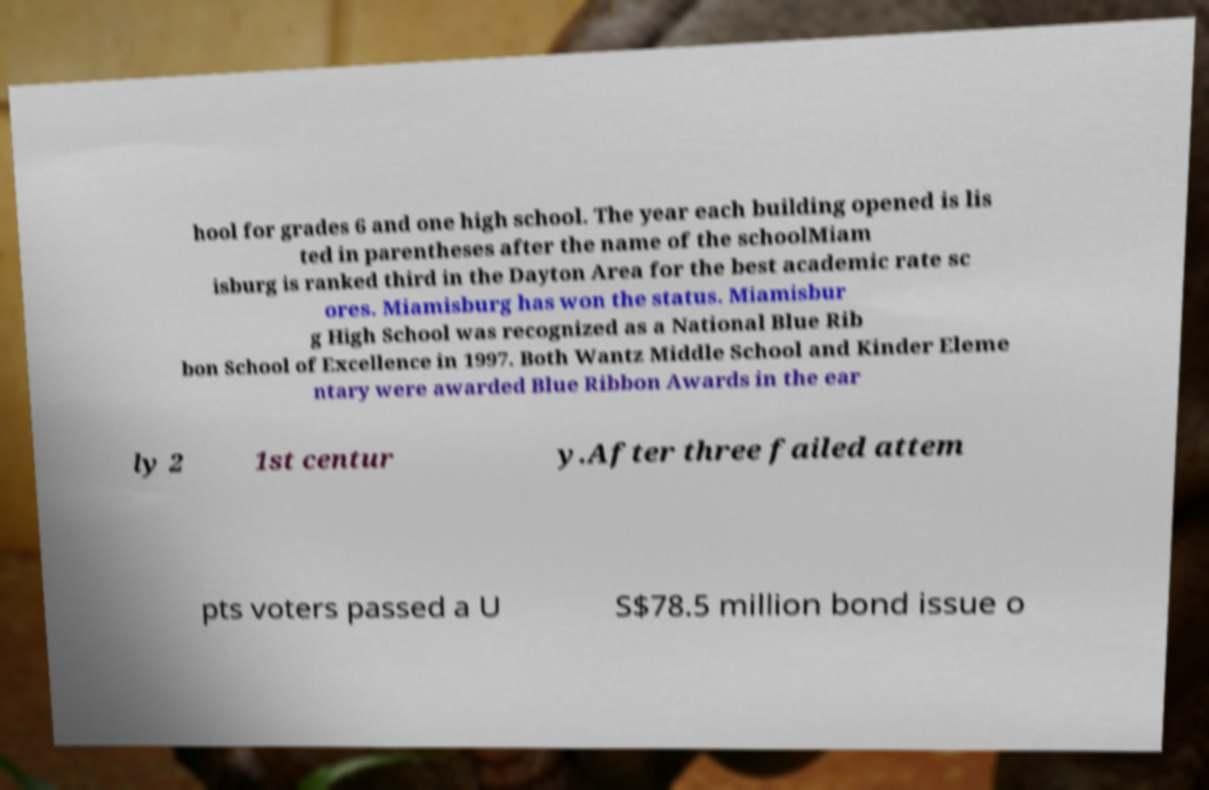Please read and relay the text visible in this image. What does it say? hool for grades 6 and one high school. The year each building opened is lis ted in parentheses after the name of the schoolMiam isburg is ranked third in the Dayton Area for the best academic rate sc ores. Miamisburg has won the status. Miamisbur g High School was recognized as a National Blue Rib bon School of Excellence in 1997. Both Wantz Middle School and Kinder Eleme ntary were awarded Blue Ribbon Awards in the ear ly 2 1st centur y.After three failed attem pts voters passed a U S$78.5 million bond issue o 